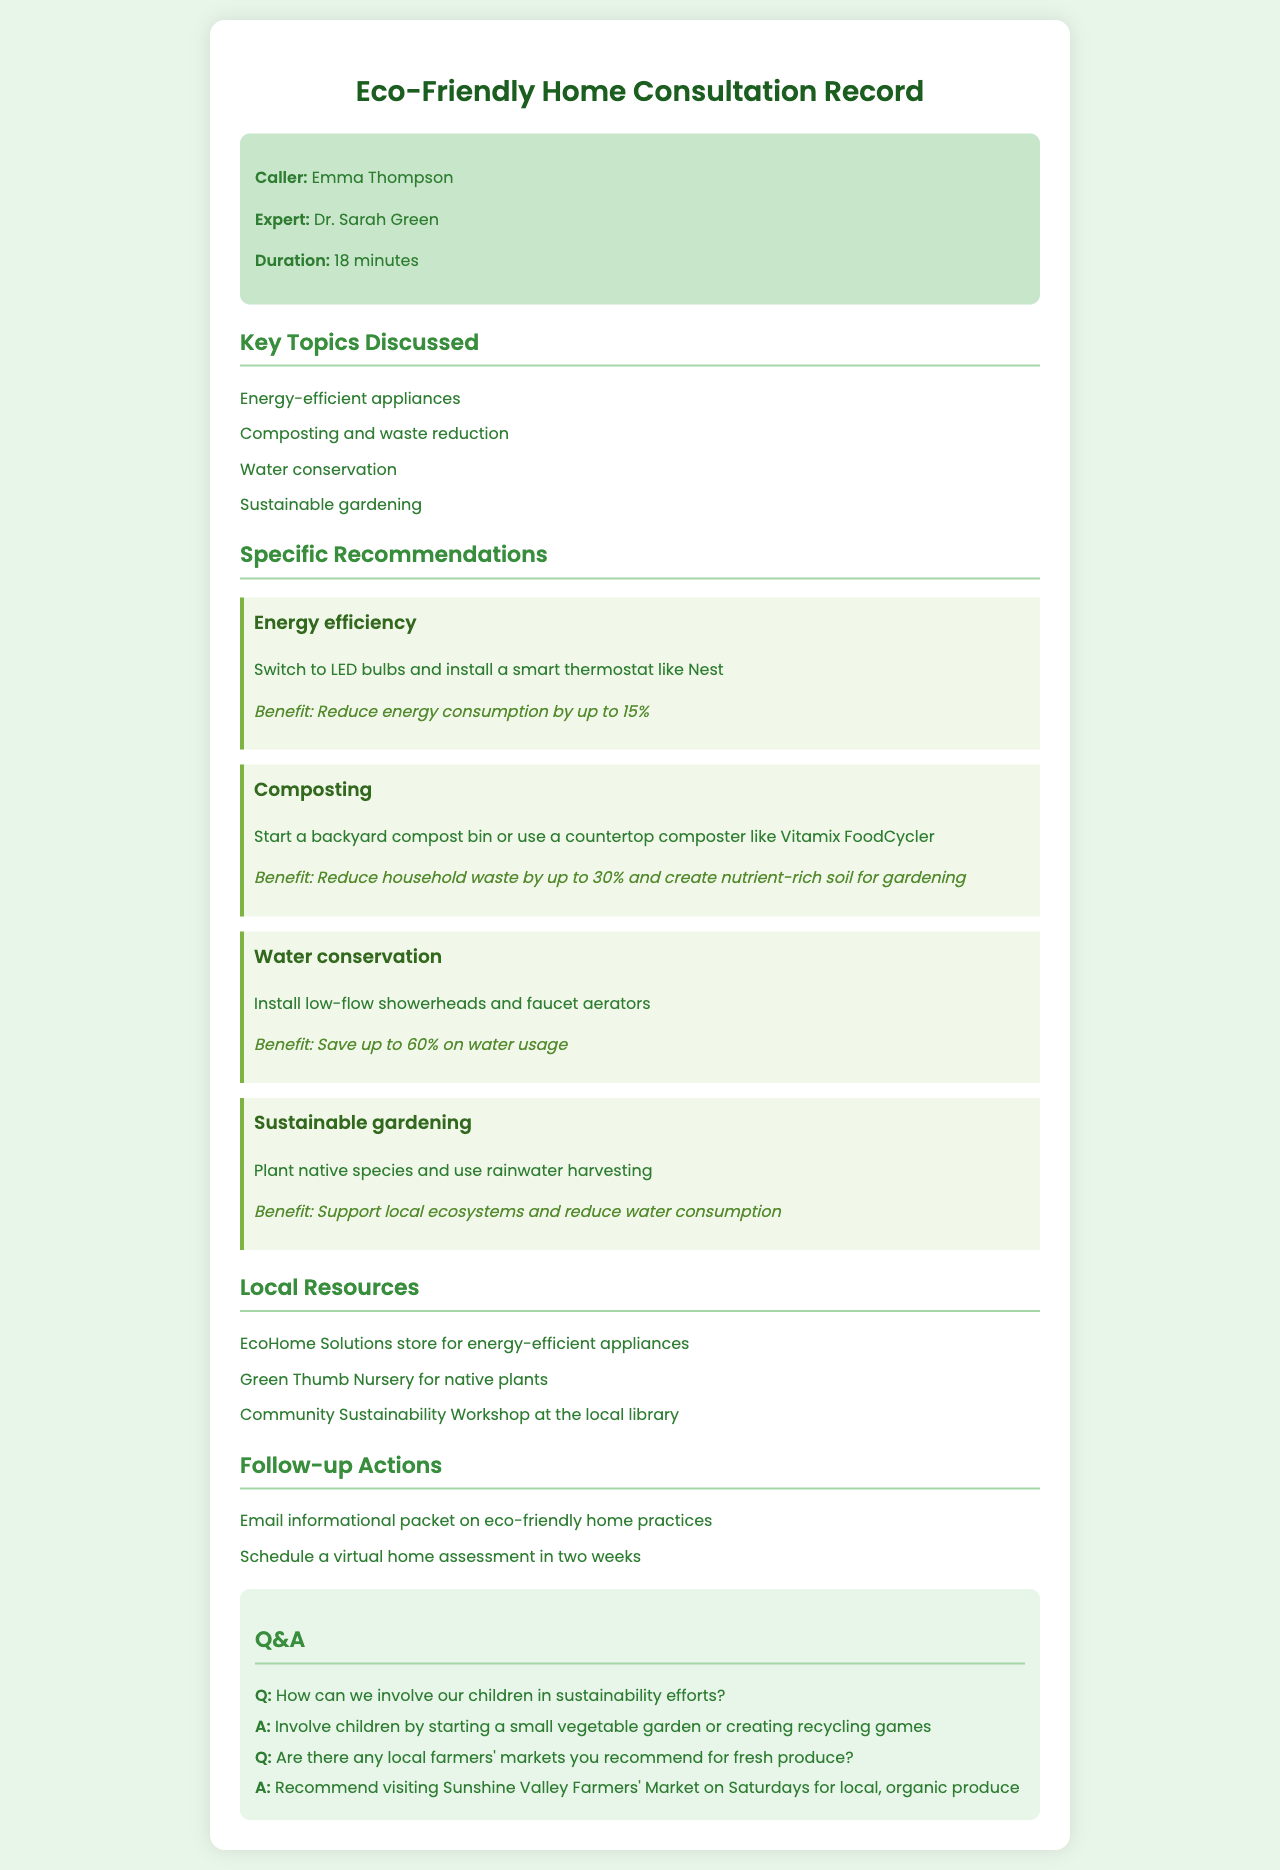What is the name of the caller? The caller's name is listed at the beginning of the call record.
Answer: Emma Thompson Who is the sustainability expert? The expert's name is also provided in the call information section.
Answer: Dr. Sarah Green How long was the consultation? The duration of the call is specified in the call information section.
Answer: 18 minutes What is one recommended energy-efficient appliance? A specific recommendation is made for a type of energy-efficient appliance under the recommendations section.
Answer: LED bulbs What is suggested for composting? The recommendations section includes a specific suggestion for composting practices.
Answer: Backyard compost bin What are two benefits of installing low-flow showerheads? The benefits of low-flow showerheads are stated in the recommendations section.
Answer: Save up to 60% on water usage What does planting native species support? The document specifies the ecological benefits related to planting native plants in the sustainable gardening section.
Answer: Local ecosystems What local resource offers energy-efficient appliances? The local resources section mentions a specific store that provides energy-efficient appliances.
Answer: EcoHome Solutions store How can families involve children in sustainability? The answer is provided in the Q&A section covering family involvement in sustainability practices.
Answer: Starting a small vegetable garden 